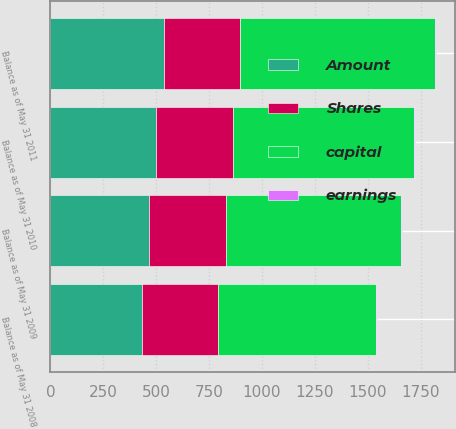<chart> <loc_0><loc_0><loc_500><loc_500><stacked_bar_chart><ecel><fcel>Balance as of May 31 2008<fcel>Balance as of May 31 2009<fcel>Balance as of May 31 2010<fcel>Balance as of May 31 2011<nl><fcel>Shares<fcel>360.5<fcel>361<fcel>361.5<fcel>362.1<nl><fcel>earnings<fcel>3.6<fcel>3.6<fcel>3.6<fcel>3.6<nl><fcel>Amount<fcel>431.6<fcel>466.4<fcel>499.7<fcel>535.6<nl><fcel>capital<fcel>745.4<fcel>829.5<fcel>856.3<fcel>919.5<nl></chart> 